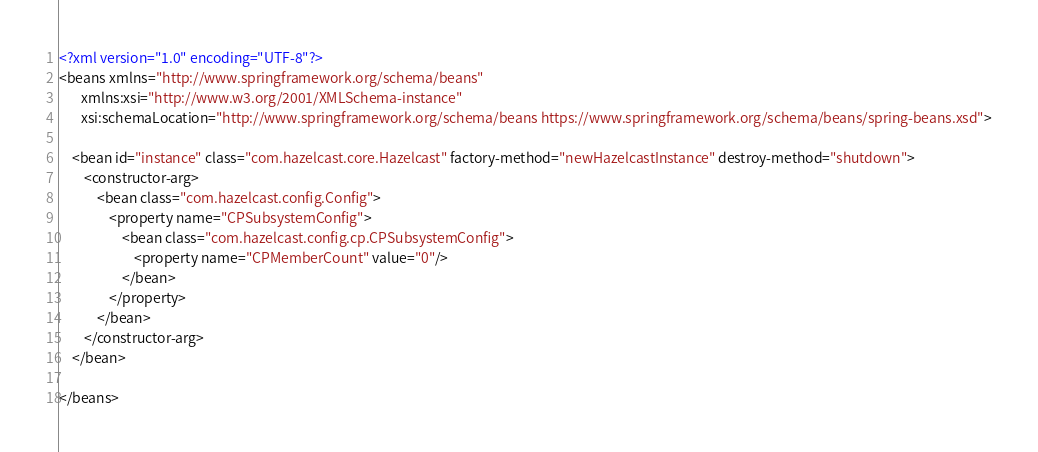<code> <loc_0><loc_0><loc_500><loc_500><_XML_><?xml version="1.0" encoding="UTF-8"?>
<beans xmlns="http://www.springframework.org/schema/beans"
	   xmlns:xsi="http://www.w3.org/2001/XMLSchema-instance"
	   xsi:schemaLocation="http://www.springframework.org/schema/beans https://www.springframework.org/schema/beans/spring-beans.xsd">

	<bean id="instance" class="com.hazelcast.core.Hazelcast" factory-method="newHazelcastInstance" destroy-method="shutdown">
		<constructor-arg>
			<bean class="com.hazelcast.config.Config">
				<property name="CPSubsystemConfig">
					<bean class="com.hazelcast.config.cp.CPSubsystemConfig">
						<property name="CPMemberCount" value="0"/>
					</bean>
				</property>
			</bean>
		</constructor-arg>
	</bean>

</beans>
</code> 